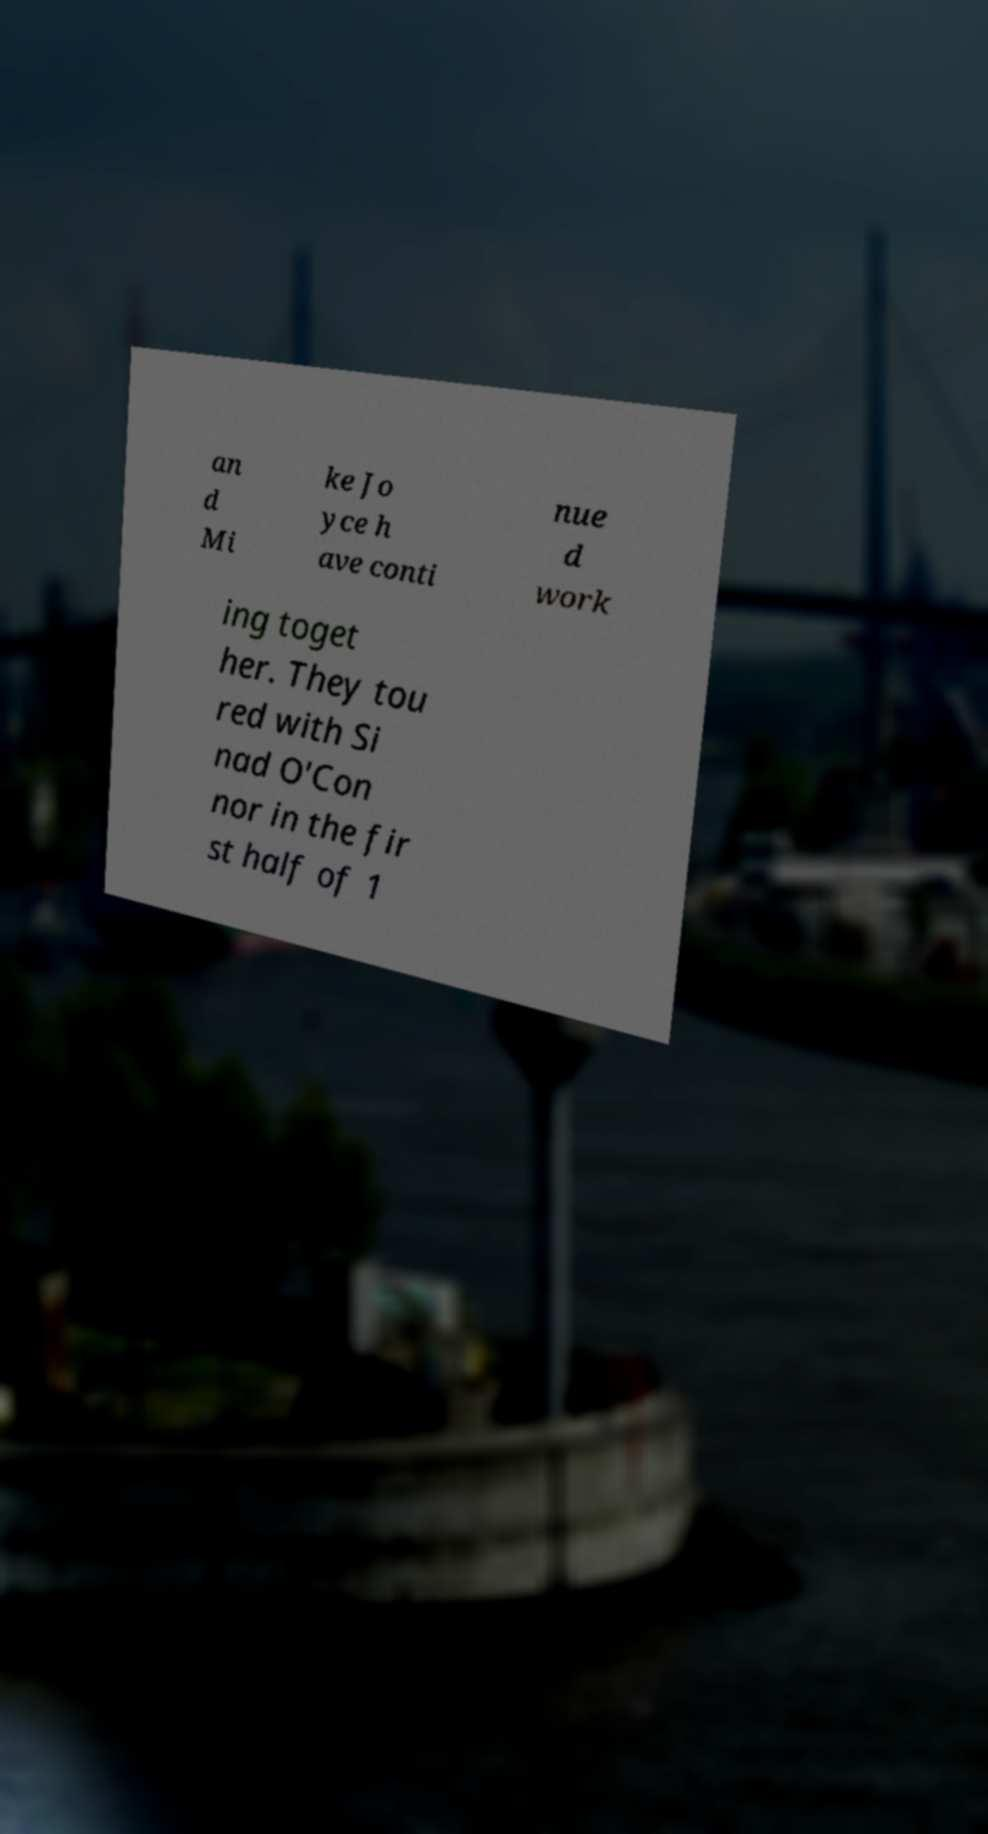What messages or text are displayed in this image? I need them in a readable, typed format. an d Mi ke Jo yce h ave conti nue d work ing toget her. They tou red with Si nad O'Con nor in the fir st half of 1 